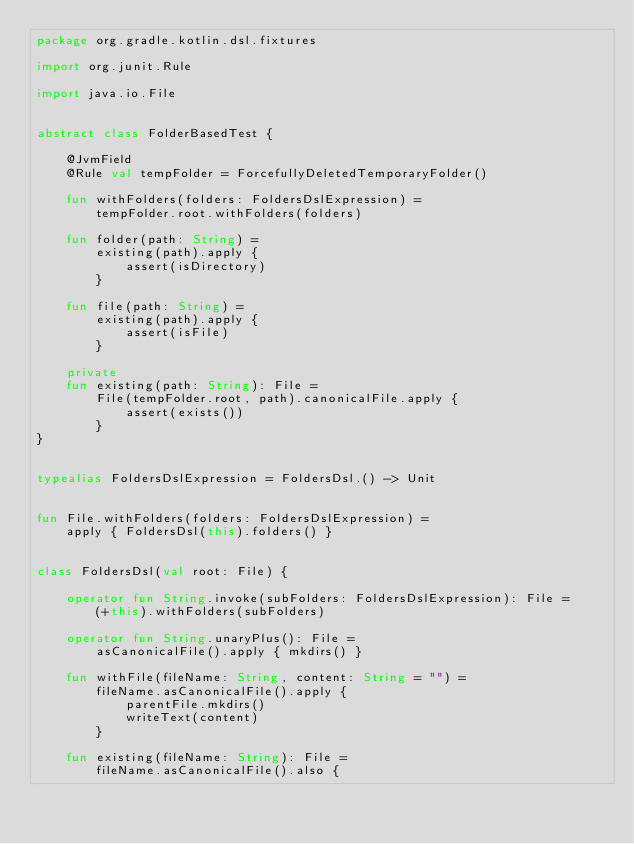<code> <loc_0><loc_0><loc_500><loc_500><_Kotlin_>package org.gradle.kotlin.dsl.fixtures

import org.junit.Rule

import java.io.File


abstract class FolderBasedTest {

    @JvmField
    @Rule val tempFolder = ForcefullyDeletedTemporaryFolder()

    fun withFolders(folders: FoldersDslExpression) =
        tempFolder.root.withFolders(folders)

    fun folder(path: String) =
        existing(path).apply {
            assert(isDirectory)
        }

    fun file(path: String) =
        existing(path).apply {
            assert(isFile)
        }

    private
    fun existing(path: String): File =
        File(tempFolder.root, path).canonicalFile.apply {
            assert(exists())
        }
}


typealias FoldersDslExpression = FoldersDsl.() -> Unit


fun File.withFolders(folders: FoldersDslExpression) =
    apply { FoldersDsl(this).folders() }


class FoldersDsl(val root: File) {

    operator fun String.invoke(subFolders: FoldersDslExpression): File =
        (+this).withFolders(subFolders)

    operator fun String.unaryPlus(): File =
        asCanonicalFile().apply { mkdirs() }

    fun withFile(fileName: String, content: String = "") =
        fileName.asCanonicalFile().apply {
            parentFile.mkdirs()
            writeText(content)
        }

    fun existing(fileName: String): File =
        fileName.asCanonicalFile().also {</code> 